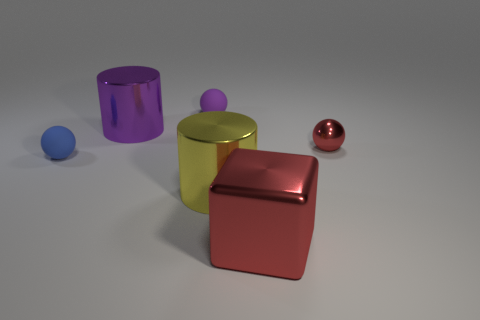The small thing that is the same color as the big shiny cube is what shape?
Offer a very short reply. Sphere. How many big objects are either green metallic objects or purple rubber things?
Your answer should be very brief. 0. Does the thing behind the purple shiny object have the same shape as the big purple thing?
Offer a terse response. No. Are there fewer blue cylinders than yellow metal cylinders?
Offer a very short reply. Yes. Is there anything else that has the same color as the cube?
Your response must be concise. Yes. There is a big thing that is behind the tiny red thing; what shape is it?
Keep it short and to the point. Cylinder. Does the big metallic block have the same color as the small ball that is to the right of the big red shiny block?
Your answer should be compact. Yes. Is the number of large red shiny objects that are behind the red metal cube the same as the number of small balls that are on the left side of the yellow shiny object?
Provide a succinct answer. No. How many other objects are there of the same size as the shiny cube?
Your answer should be very brief. 2. What is the size of the metallic cube?
Your response must be concise. Large. 